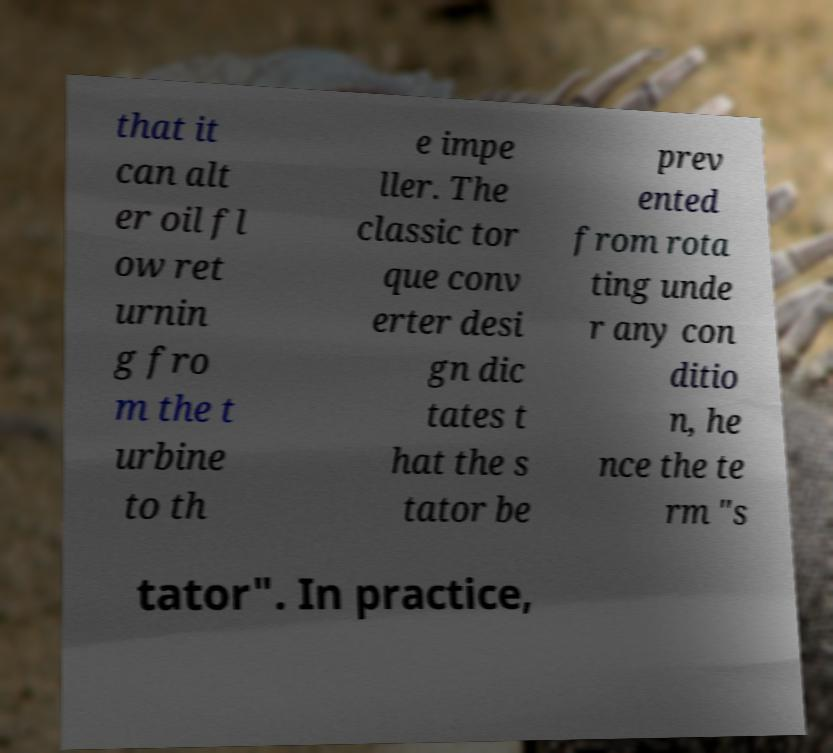Can you read and provide the text displayed in the image?This photo seems to have some interesting text. Can you extract and type it out for me? that it can alt er oil fl ow ret urnin g fro m the t urbine to th e impe ller. The classic tor que conv erter desi gn dic tates t hat the s tator be prev ented from rota ting unde r any con ditio n, he nce the te rm "s tator". In practice, 